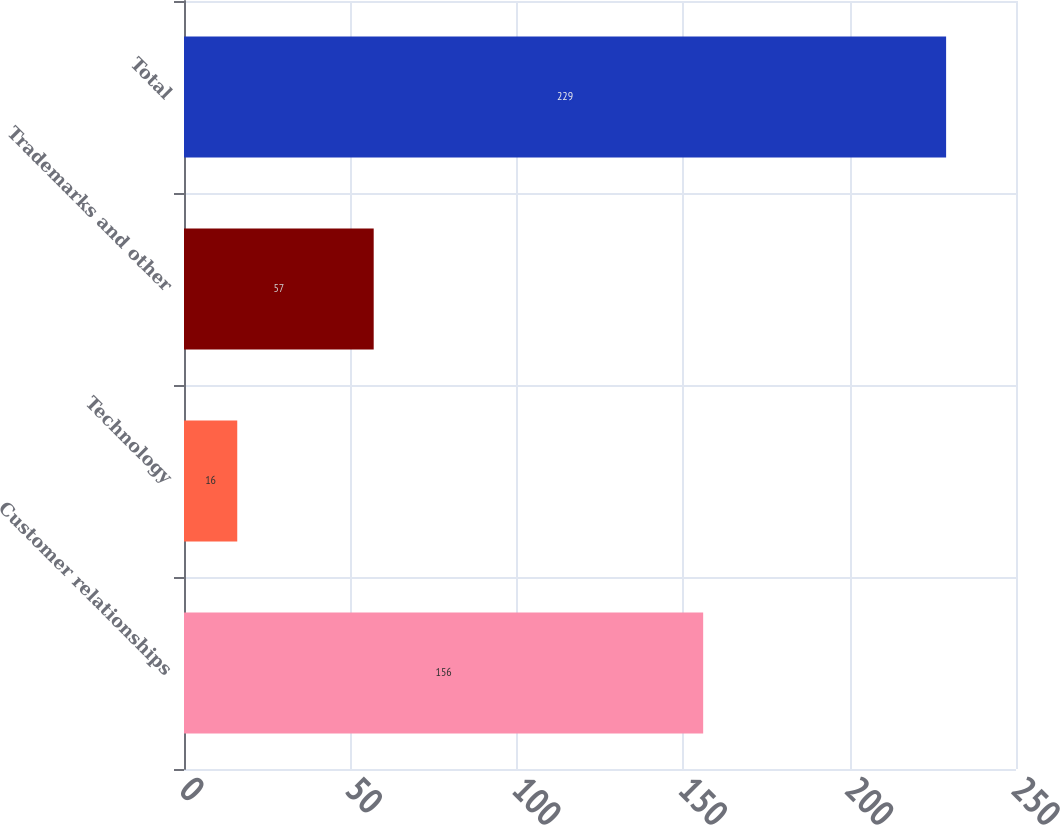Convert chart. <chart><loc_0><loc_0><loc_500><loc_500><bar_chart><fcel>Customer relationships<fcel>Technology<fcel>Trademarks and other<fcel>Total<nl><fcel>156<fcel>16<fcel>57<fcel>229<nl></chart> 